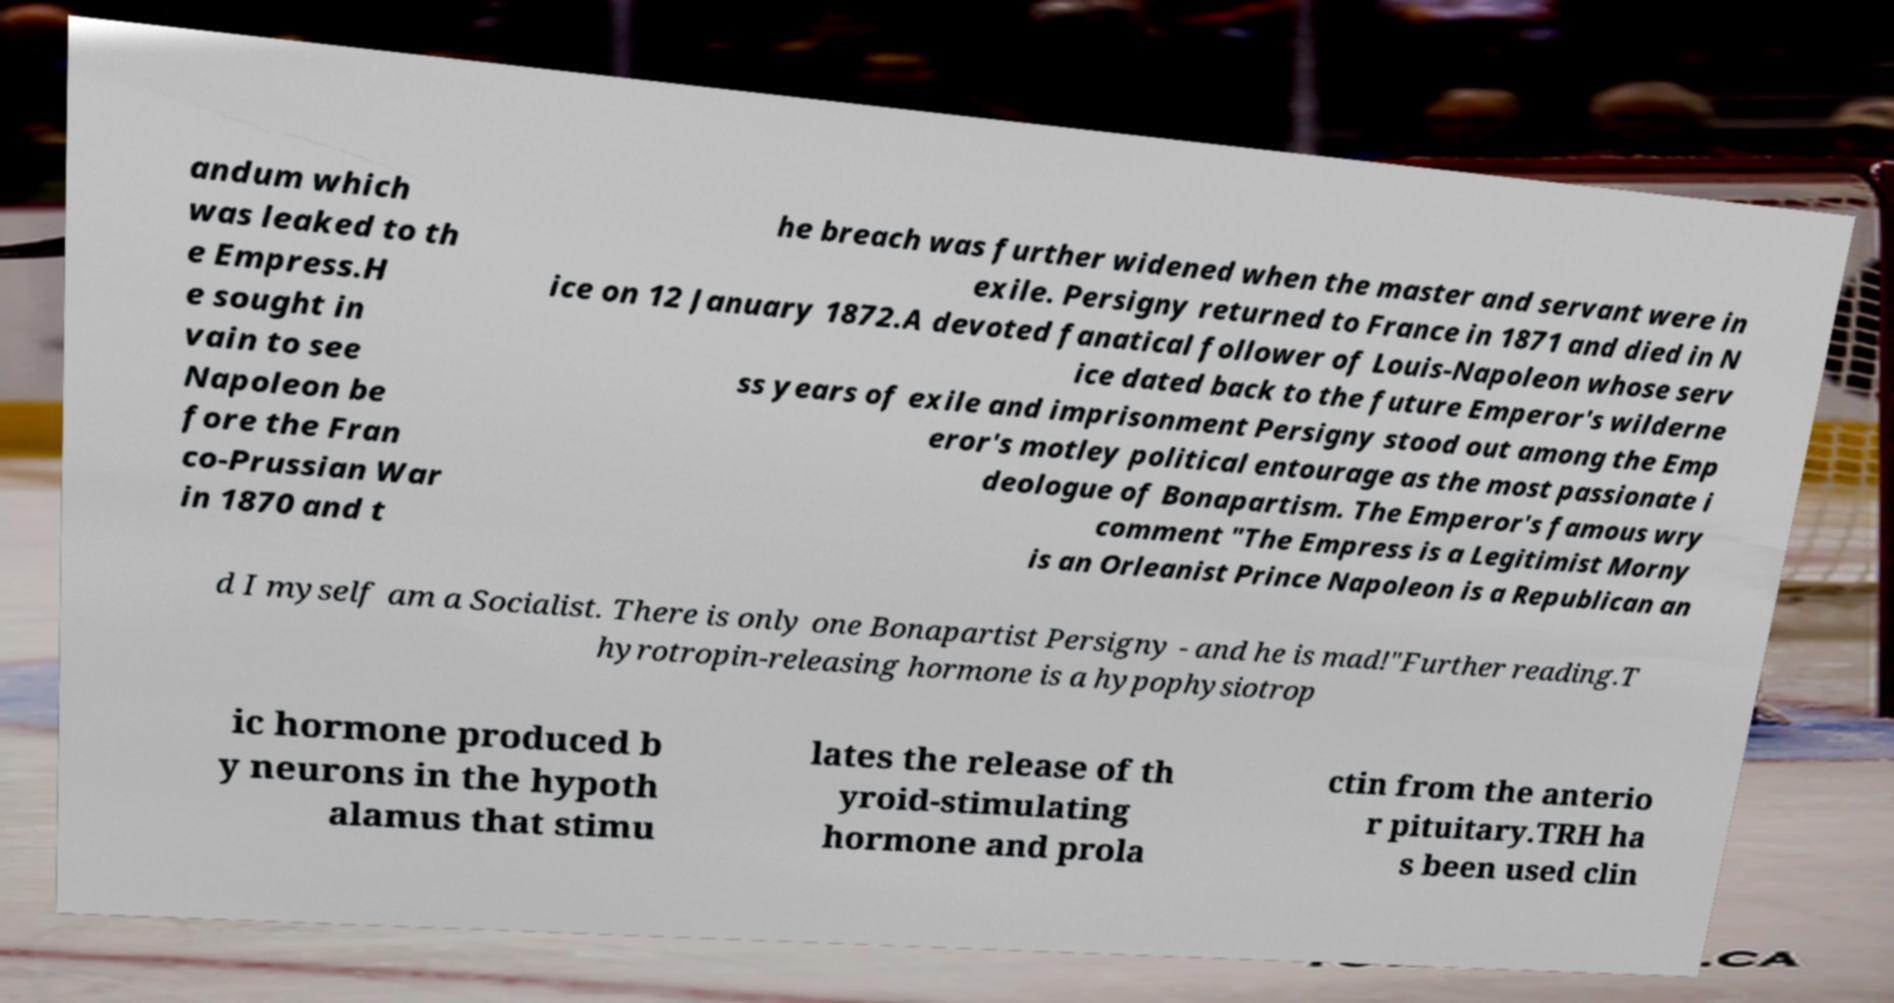Could you extract and type out the text from this image? andum which was leaked to th e Empress.H e sought in vain to see Napoleon be fore the Fran co-Prussian War in 1870 and t he breach was further widened when the master and servant were in exile. Persigny returned to France in 1871 and died in N ice on 12 January 1872.A devoted fanatical follower of Louis-Napoleon whose serv ice dated back to the future Emperor's wilderne ss years of exile and imprisonment Persigny stood out among the Emp eror's motley political entourage as the most passionate i deologue of Bonapartism. The Emperor's famous wry comment "The Empress is a Legitimist Morny is an Orleanist Prince Napoleon is a Republican an d I myself am a Socialist. There is only one Bonapartist Persigny - and he is mad!"Further reading.T hyrotropin-releasing hormone is a hypophysiotrop ic hormone produced b y neurons in the hypoth alamus that stimu lates the release of th yroid-stimulating hormone and prola ctin from the anterio r pituitary.TRH ha s been used clin 